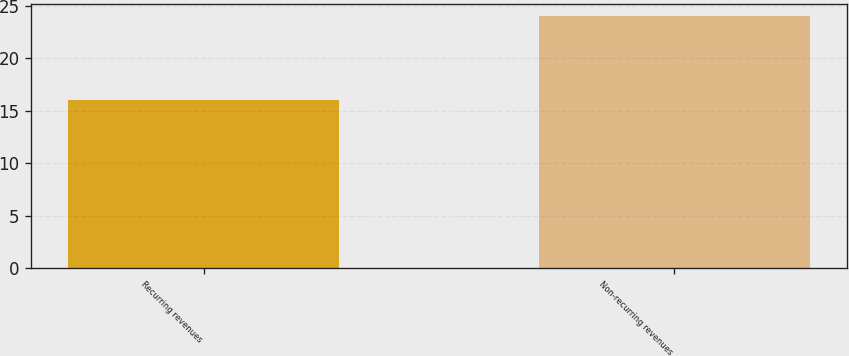Convert chart. <chart><loc_0><loc_0><loc_500><loc_500><bar_chart><fcel>Recurring revenues<fcel>Non-recurring revenues<nl><fcel>16<fcel>24<nl></chart> 